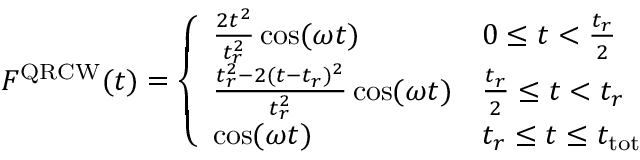Convert formula to latex. <formula><loc_0><loc_0><loc_500><loc_500>F ^ { Q R C W } ( t ) = \left \{ \begin{array} { l l } { \frac { 2 t ^ { 2 } } { t _ { r } ^ { 2 } } \cos ( \omega t ) } & { 0 \leq t < \frac { t _ { r } } { 2 } } \\ { \frac { t _ { r } ^ { 2 } - 2 ( t - t _ { r } ) ^ { 2 } } { t _ { r } ^ { 2 } } \cos ( \omega t ) } & { \frac { t _ { r } } { 2 } \leq t < t _ { r } } \\ { \cos ( \omega t ) } & { t _ { r } \leq t \leq t _ { t o t } } \end{array}</formula> 